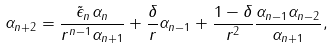<formula> <loc_0><loc_0><loc_500><loc_500>\alpha _ { n + 2 } = \frac { \tilde { \epsilon } _ { n } \alpha _ { n } } { r ^ { n - 1 } \alpha _ { n + 1 } } + \frac { \delta } { r } \alpha _ { n - 1 } + \frac { 1 - \delta } { r ^ { 2 } } \frac { \alpha _ { n - 1 } \alpha _ { n - 2 } } { \alpha _ { n + 1 } } ,</formula> 